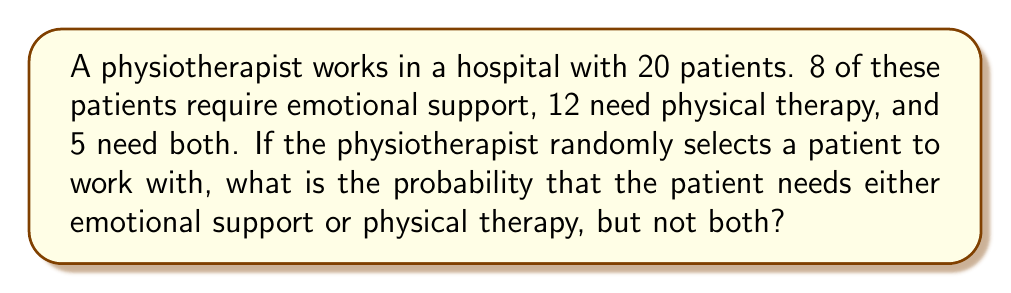Can you answer this question? Let's approach this step-by-step using set theory and probability:

1) Let E be the set of patients needing emotional support, and P be the set of patients needing physical therapy.

2) We're given:
   $|E| = 8$ (number of patients needing emotional support)
   $|P| = 12$ (number of patients needing physical therapy)
   $|E \cap P| = 5$ (number of patients needing both)
   Total patients = 20

3) We need to find $P(E \cup P) - P(E \cap P)$

4) First, let's find $|E \cup P|$ using the inclusion-exclusion principle:
   $|E \cup P| = |E| + |P| - |E \cap P|$
   $|E \cup P| = 8 + 12 - 5 = 15$

5) Now, the probability of selecting a patient needing either emotional support or physical therapy:
   $P(E \cup P) = \frac{|E \cup P|}{20} = \frac{15}{20}$

6) The probability of selecting a patient needing both:
   $P(E \cap P) = \frac{|E \cap P|}{20} = \frac{5}{20}$

7) Therefore, the probability of selecting a patient needing either emotional support or physical therapy, but not both:
   $P((E \cup P) - (E \cap P)) = P(E \cup P) - P(E \cap P) = \frac{15}{20} - \frac{5}{20} = \frac{10}{20} = \frac{1}{2}$
Answer: $\frac{1}{2}$ 